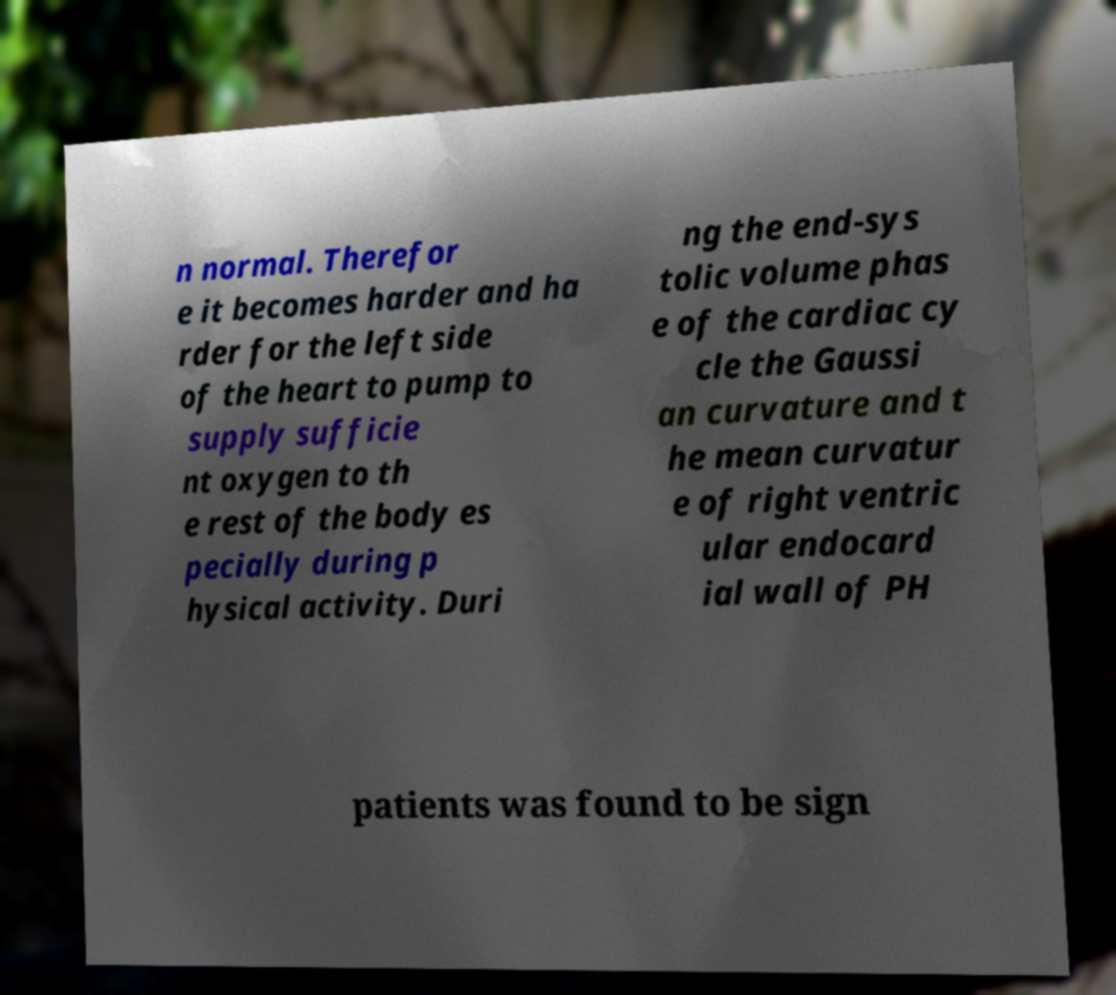There's text embedded in this image that I need extracted. Can you transcribe it verbatim? n normal. Therefor e it becomes harder and ha rder for the left side of the heart to pump to supply sufficie nt oxygen to th e rest of the body es pecially during p hysical activity. Duri ng the end-sys tolic volume phas e of the cardiac cy cle the Gaussi an curvature and t he mean curvatur e of right ventric ular endocard ial wall of PH patients was found to be sign 